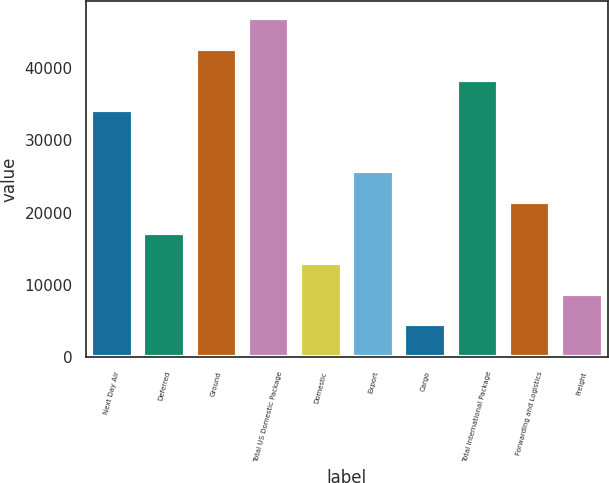<chart> <loc_0><loc_0><loc_500><loc_500><bar_chart><fcel>Next Day Air<fcel>Deferred<fcel>Ground<fcel>Total US Domestic Package<fcel>Domestic<fcel>Export<fcel>Cargo<fcel>Total International Package<fcel>Forwarding and Logistics<fcel>Freight<nl><fcel>34132.4<fcel>17235.2<fcel>42581<fcel>46805.3<fcel>13010.9<fcel>25683.8<fcel>4562.3<fcel>38356.7<fcel>21459.5<fcel>8786.6<nl></chart> 